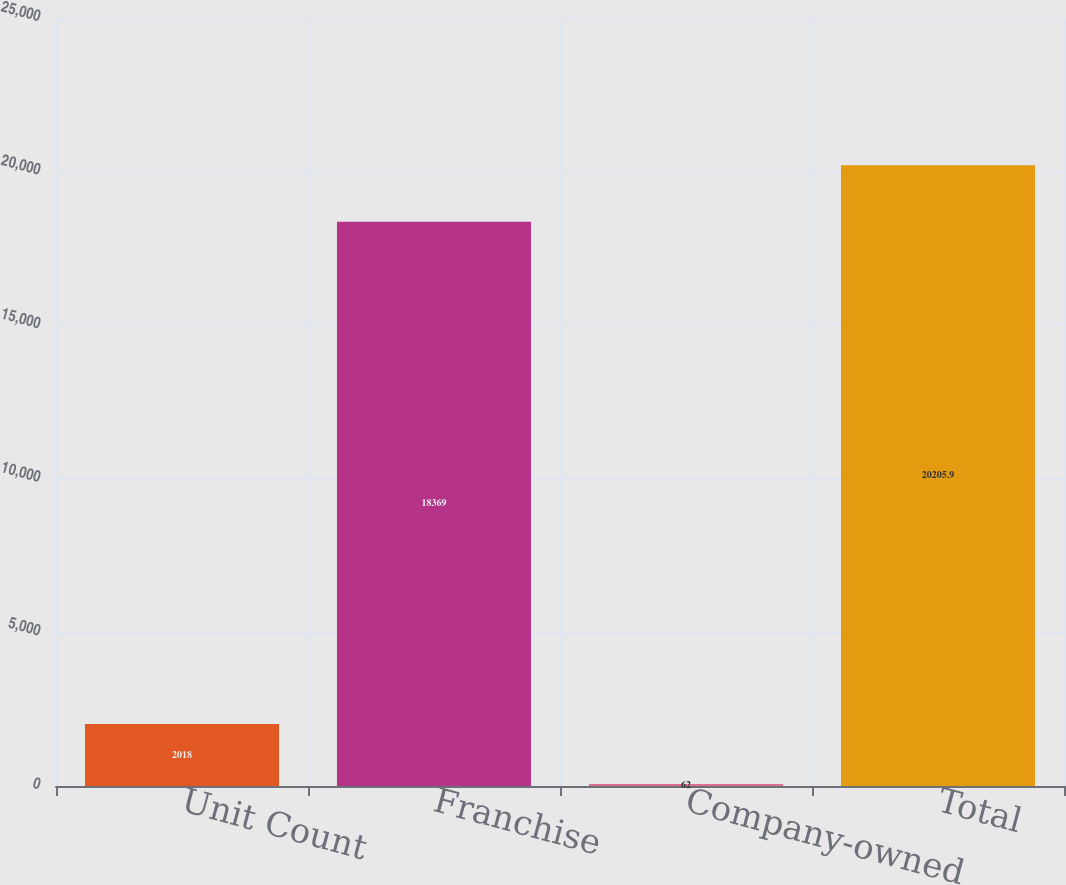Convert chart. <chart><loc_0><loc_0><loc_500><loc_500><bar_chart><fcel>Unit Count<fcel>Franchise<fcel>Company-owned<fcel>Total<nl><fcel>2018<fcel>18369<fcel>62<fcel>20205.9<nl></chart> 